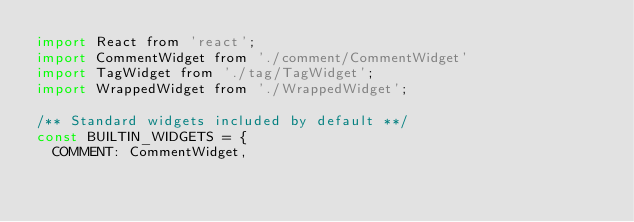<code> <loc_0><loc_0><loc_500><loc_500><_JavaScript_>import React from 'react';
import CommentWidget from './comment/CommentWidget'
import TagWidget from './tag/TagWidget';
import WrappedWidget from './WrappedWidget';

/** Standard widgets included by default **/
const BUILTIN_WIDGETS = {
  COMMENT: CommentWidget,</code> 